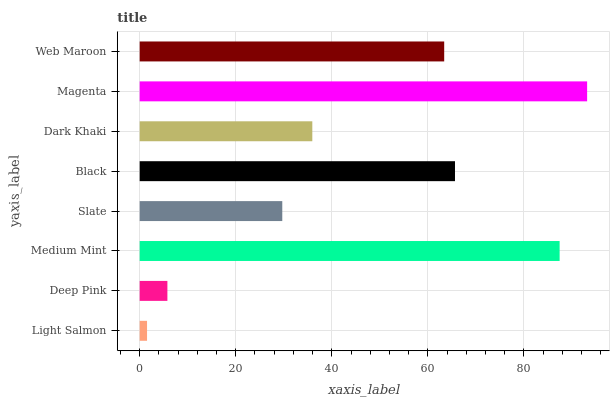Is Light Salmon the minimum?
Answer yes or no. Yes. Is Magenta the maximum?
Answer yes or no. Yes. Is Deep Pink the minimum?
Answer yes or no. No. Is Deep Pink the maximum?
Answer yes or no. No. Is Deep Pink greater than Light Salmon?
Answer yes or no. Yes. Is Light Salmon less than Deep Pink?
Answer yes or no. Yes. Is Light Salmon greater than Deep Pink?
Answer yes or no. No. Is Deep Pink less than Light Salmon?
Answer yes or no. No. Is Web Maroon the high median?
Answer yes or no. Yes. Is Dark Khaki the low median?
Answer yes or no. Yes. Is Black the high median?
Answer yes or no. No. Is Light Salmon the low median?
Answer yes or no. No. 